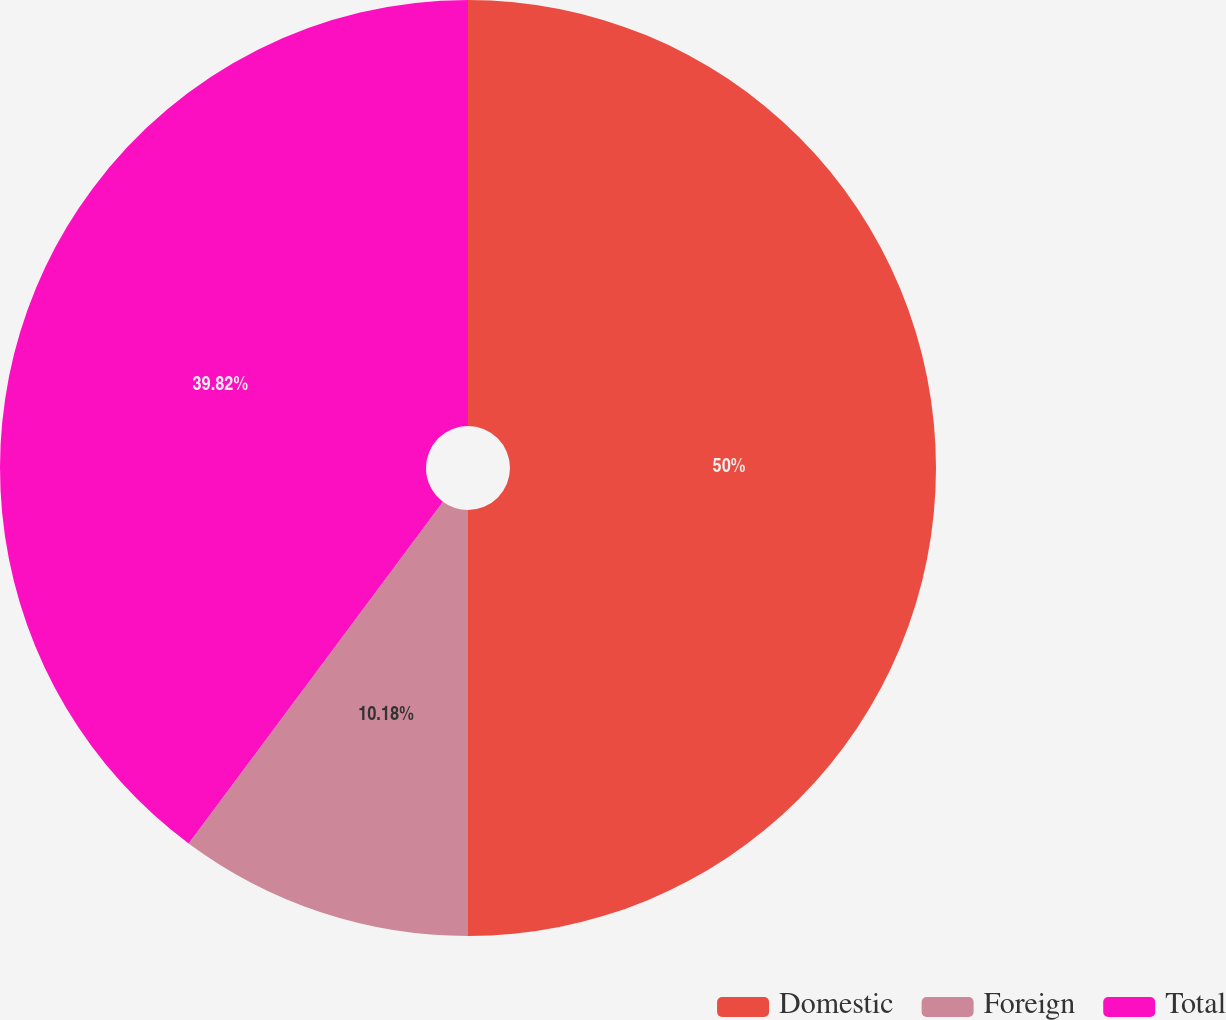Convert chart to OTSL. <chart><loc_0><loc_0><loc_500><loc_500><pie_chart><fcel>Domestic<fcel>Foreign<fcel>Total<nl><fcel>50.0%<fcel>10.18%<fcel>39.82%<nl></chart> 